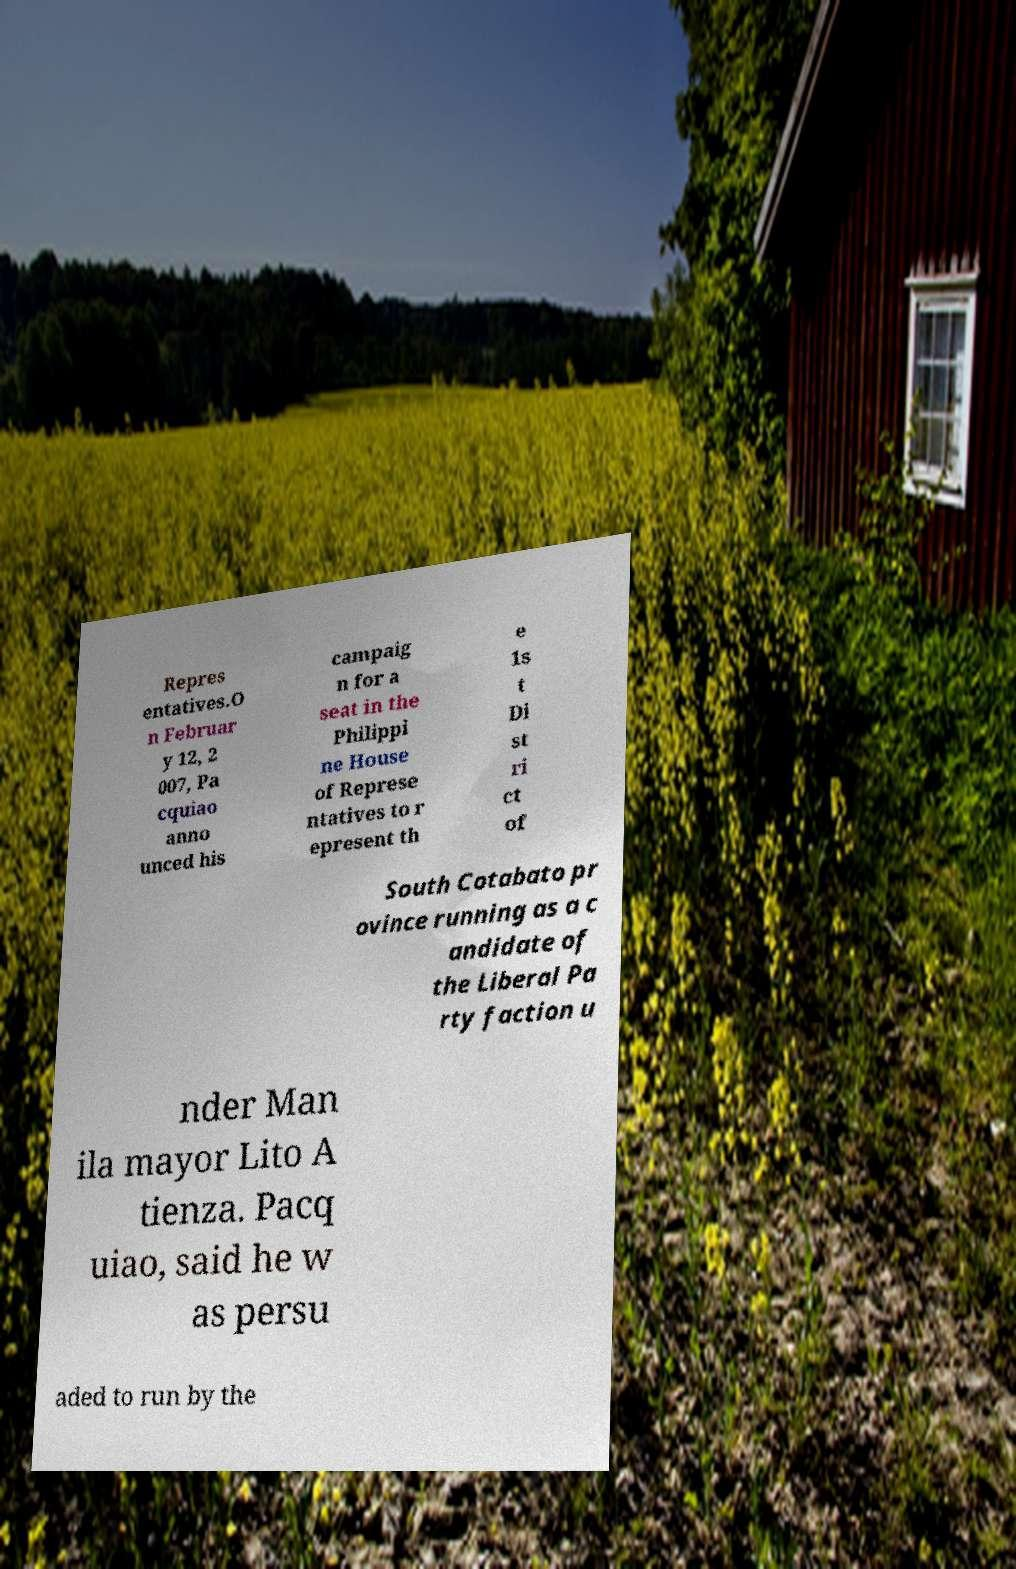Can you accurately transcribe the text from the provided image for me? Repres entatives.O n Februar y 12, 2 007, Pa cquiao anno unced his campaig n for a seat in the Philippi ne House of Represe ntatives to r epresent th e 1s t Di st ri ct of South Cotabato pr ovince running as a c andidate of the Liberal Pa rty faction u nder Man ila mayor Lito A tienza. Pacq uiao, said he w as persu aded to run by the 